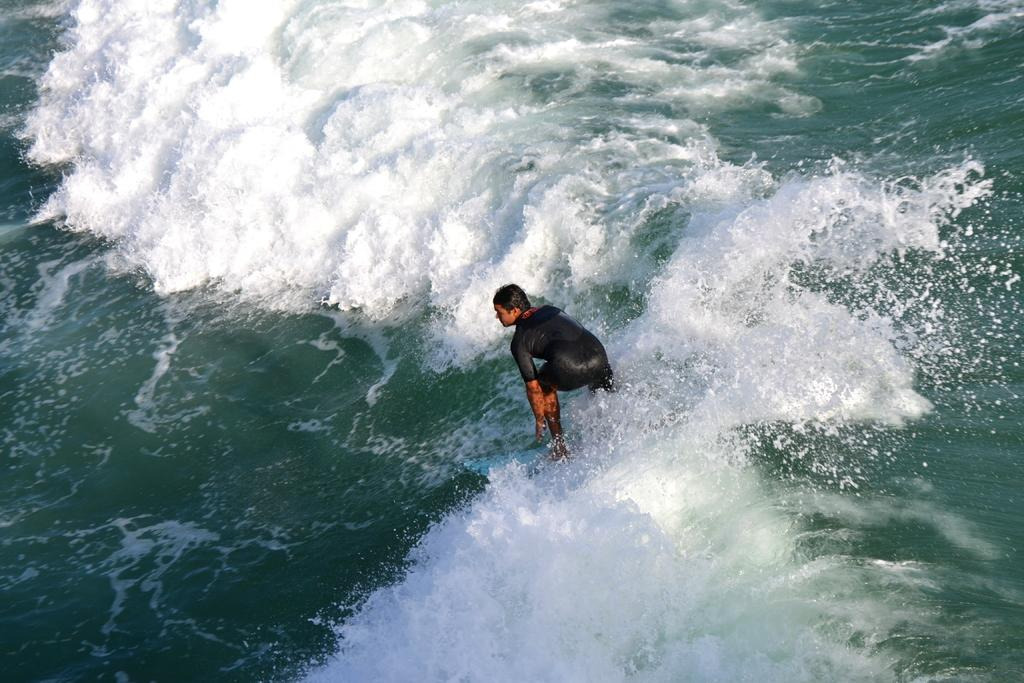What is happening in the image? There is a person in the image, and they are surfing on the water. Can you describe the person's activity in more detail? The person is standing on a surfboard and riding the waves on the water. What type of branch can be seen in the image? There is no branch present in the image; it features a person surfing on the water. What season is depicted in the image? The image does not depict a specific season, but the presence of water suggests it could be summer or a warm day. 